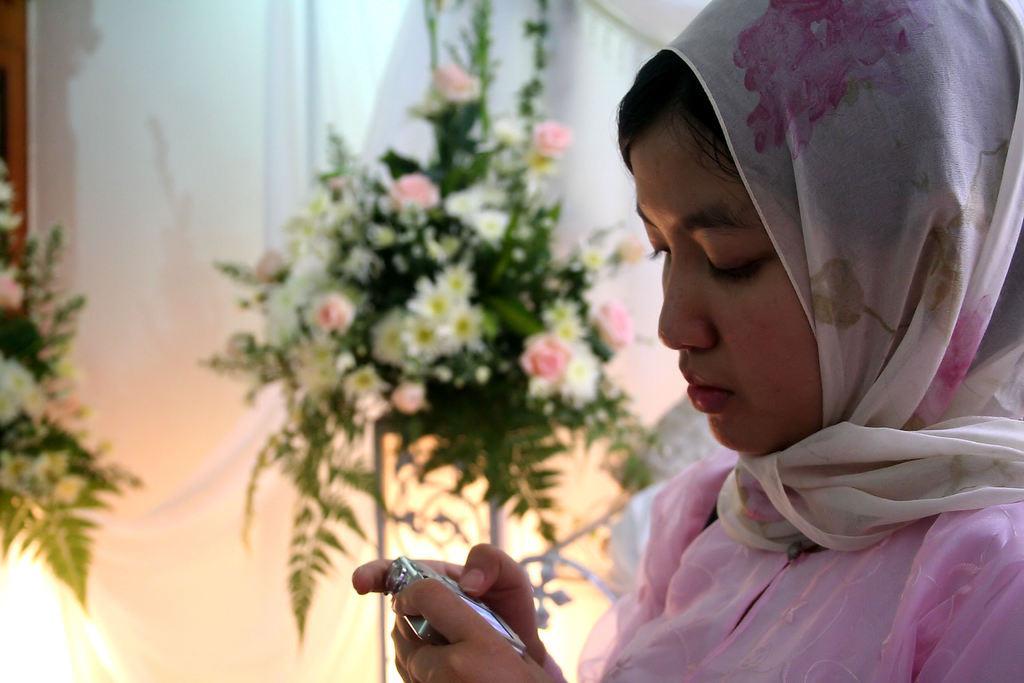Can you describe this image briefly? In this picture we can see a woman holding a camera with her hands and in the background we can see flowers. 